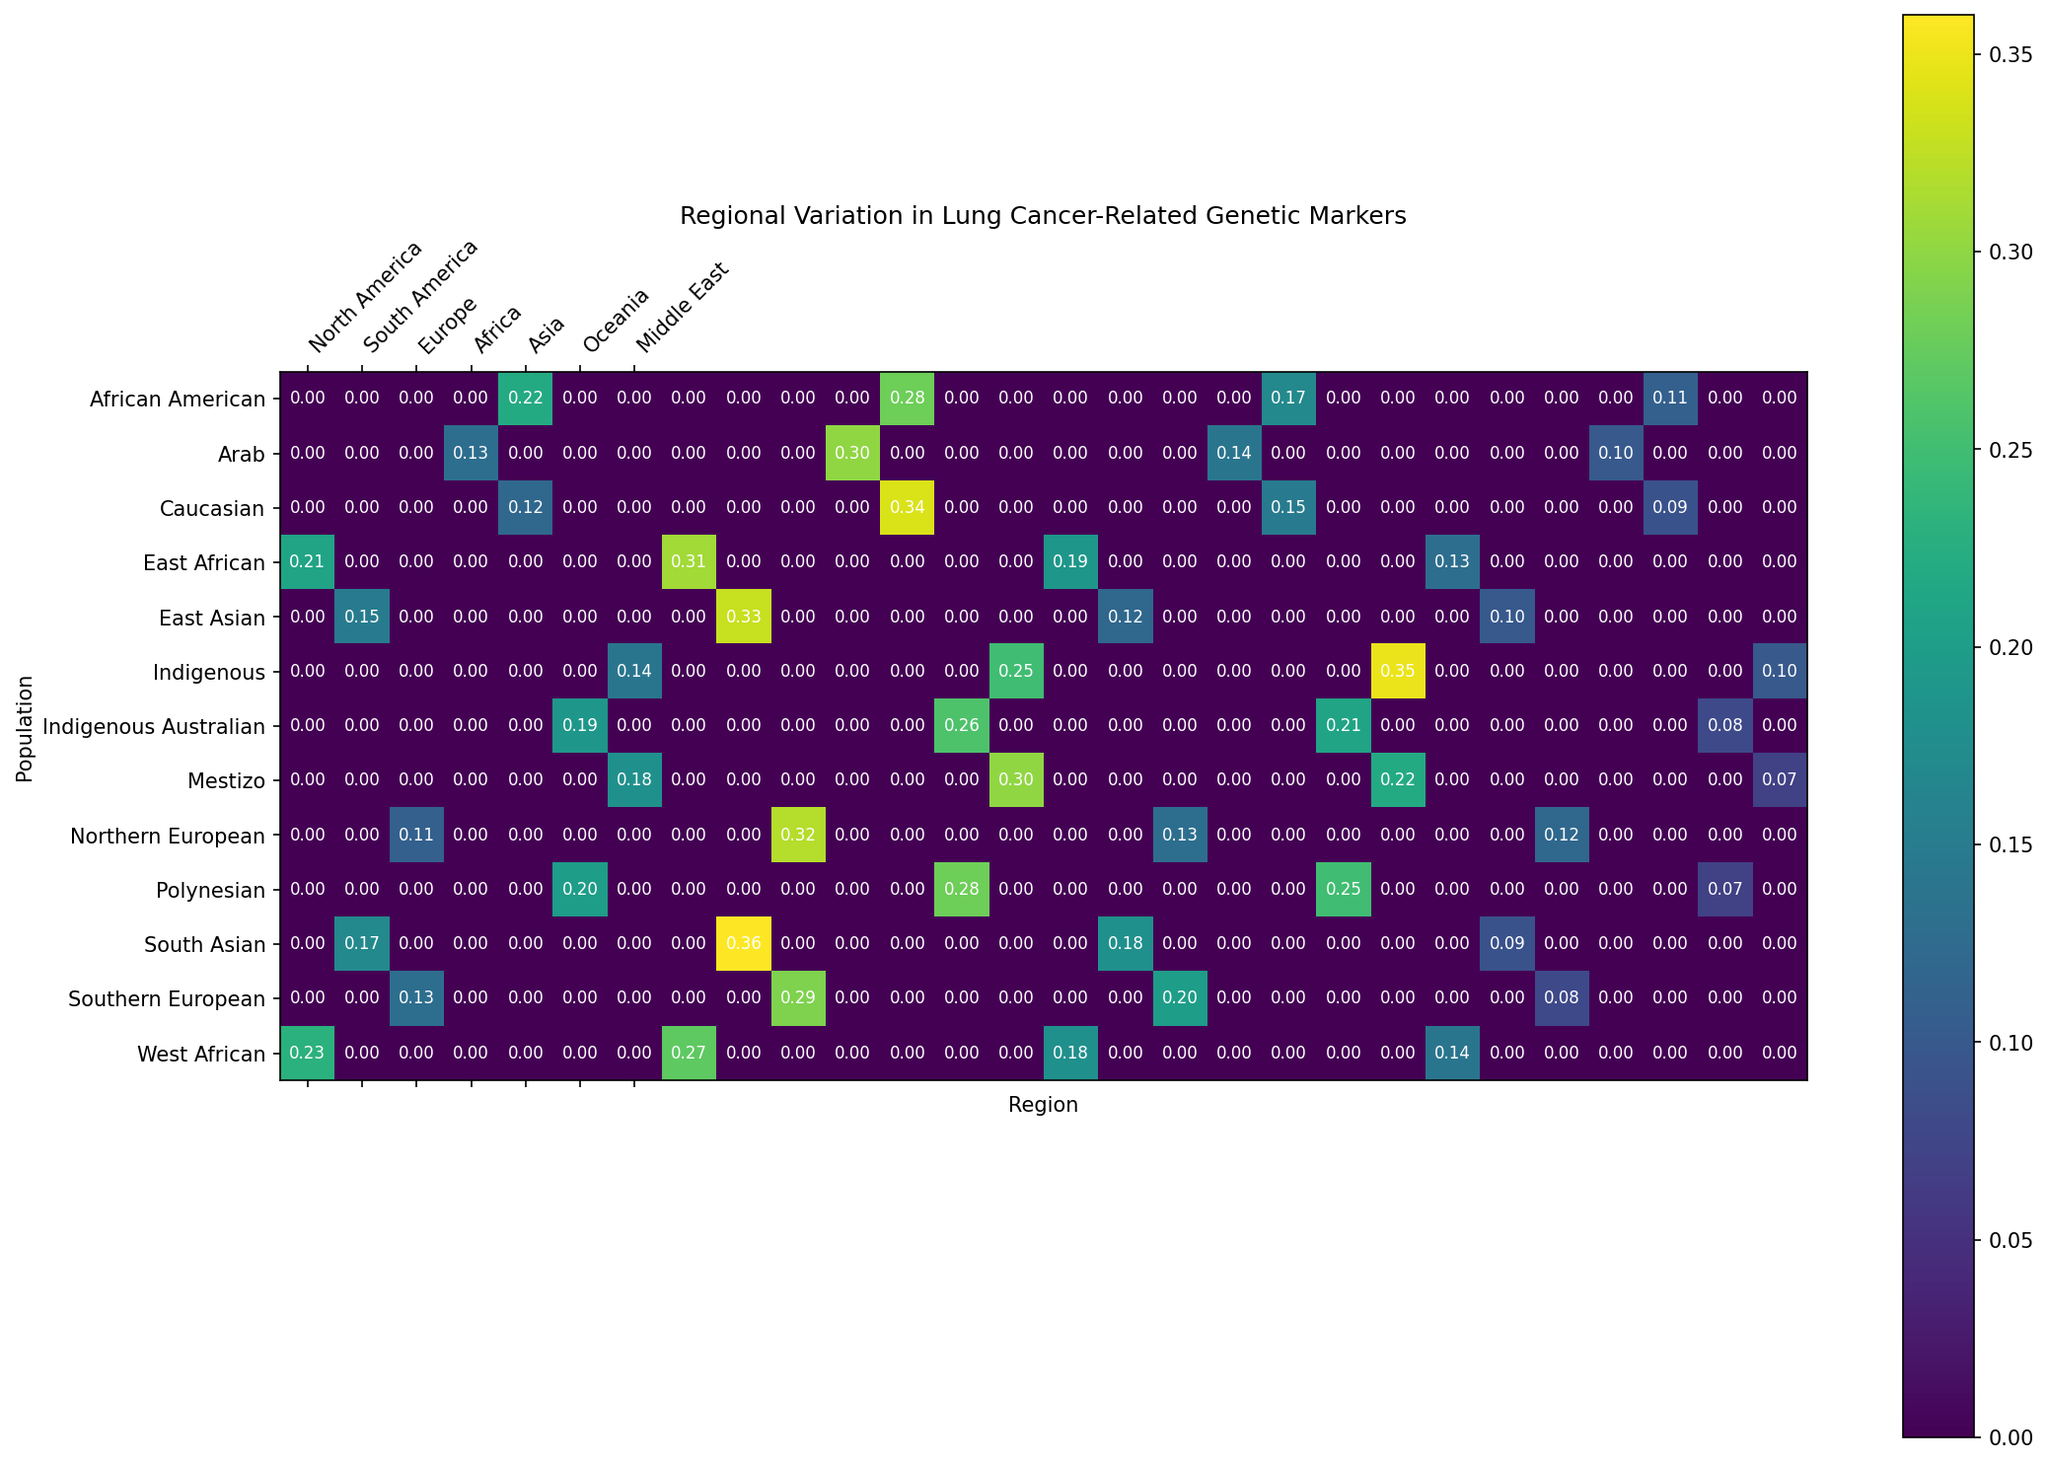Which region has the highest frequency of Marker_A in any population? By looking at the heatmap, the color intensity of Marker_A in East African population looks the darkest among all regions, which suggests the highest frequency.
Answer: Africa How does the frequency of Marker_B in the South Asian population compare to that in the Southern European population? By examining the heatmap, Marker_B in the South Asian population is visually darker than in the Southern European population, indicating a higher frequency.
Answer: Higher Which population in North America has a higher frequency of Marker_D, Caucasian or African American? Looking at the color intensity for Marker_D, African American has a slightly darker color indicating a higher frequency compared to Caucasian.
Answer: African American What is the difference in frequency of Marker_C between Northern European and Indigenous in South America? From the heatmap, the frequency of Marker_C is 0.13 for Northern European and 0.35 for Indigenous in South America. The difference is calculated as 0.35 - 0.13 = 0.22.
Answer: 0.22 Which population within Oceania shows the highest frequency for Marker_C? Comparing the color intensities, Polynesian population shows a darker shade indicating a higher frequency for Marker_C compared to Indigenous Australians.
Answer: Polynesian Is the frequency of Marker_A in the West African population higher or lower than the frequency in the East African population? Inspecting the color intensity for Marker_A, West African shows a slightly darker color than East African, indicating higher frequency.
Answer: Higher Which two populations have the closest frequencies for Marker_B? By comparing the shades, African American and Southern European populations have very similar colors for Marker_B, suggesting similar frequencies.
Answer: African American and Southern European What is the average frequency of Marker_D across all populations in the Middle East and Oceania regions? The frequencies for Marker_D are 0.10 for Arab, 0.08 for Indigenous Australian, and 0.07 for Polynesian. The average is (0.10 + 0.08 + 0.07) / 3 = 0.083.
Answer: 0.083 Which marker shows the least variation in frequency across populations in Asia? Observing the uniformity of colors across all populations in Asia for each marker, Marker_D shows least variation because the color intensity is most uniform.
Answer: Marker_D 